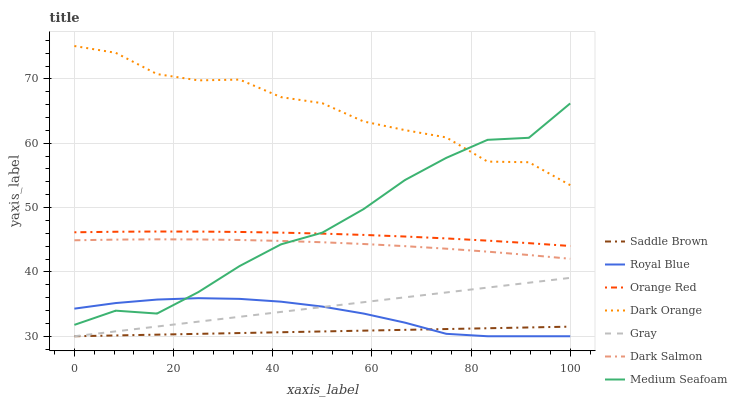Does Saddle Brown have the minimum area under the curve?
Answer yes or no. Yes. Does Dark Orange have the maximum area under the curve?
Answer yes or no. Yes. Does Gray have the minimum area under the curve?
Answer yes or no. No. Does Gray have the maximum area under the curve?
Answer yes or no. No. Is Gray the smoothest?
Answer yes or no. Yes. Is Dark Orange the roughest?
Answer yes or no. Yes. Is Dark Salmon the smoothest?
Answer yes or no. No. Is Dark Salmon the roughest?
Answer yes or no. No. Does Gray have the lowest value?
Answer yes or no. Yes. Does Dark Salmon have the lowest value?
Answer yes or no. No. Does Dark Orange have the highest value?
Answer yes or no. Yes. Does Gray have the highest value?
Answer yes or no. No. Is Gray less than Orange Red?
Answer yes or no. Yes. Is Dark Salmon greater than Gray?
Answer yes or no. Yes. Does Gray intersect Saddle Brown?
Answer yes or no. Yes. Is Gray less than Saddle Brown?
Answer yes or no. No. Is Gray greater than Saddle Brown?
Answer yes or no. No. Does Gray intersect Orange Red?
Answer yes or no. No. 